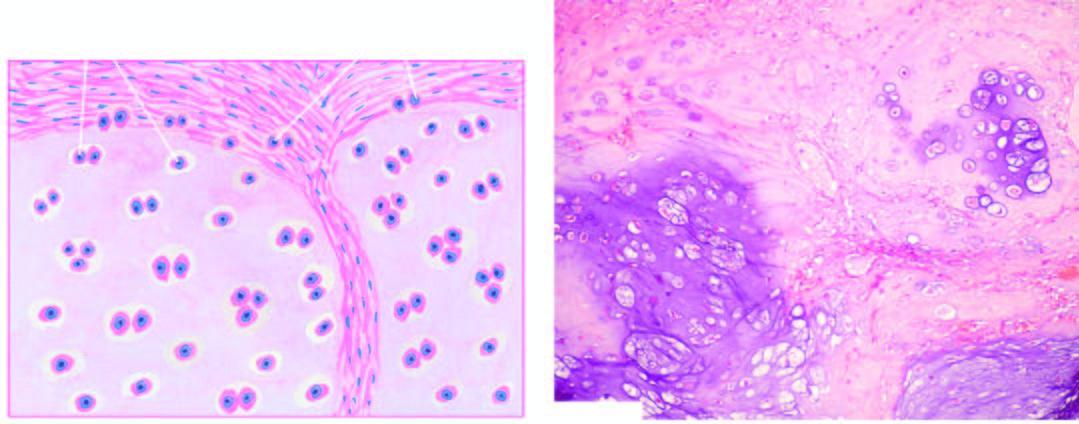do cells include invasion of the tumour into adjacent soft tissues and cytologic characteristics of malignancy in the tumour cells?
Answer the question using a single word or phrase. No 